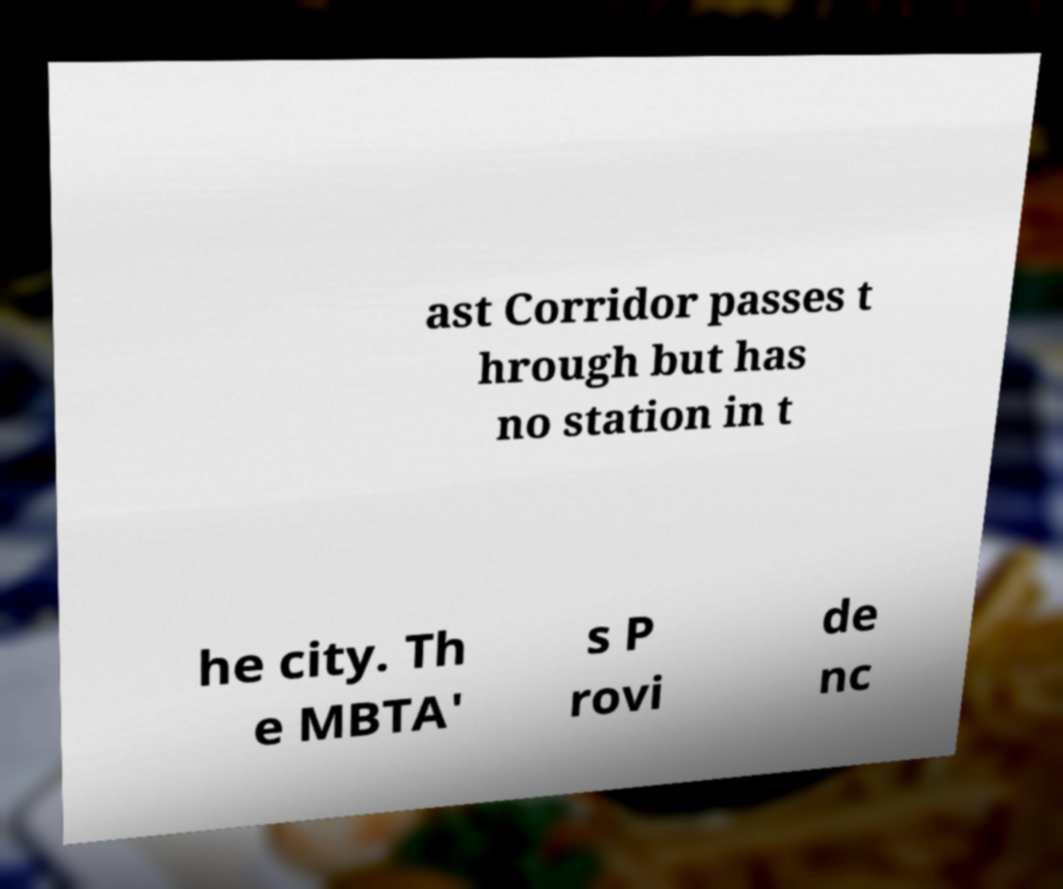There's text embedded in this image that I need extracted. Can you transcribe it verbatim? ast Corridor passes t hrough but has no station in t he city. Th e MBTA' s P rovi de nc 